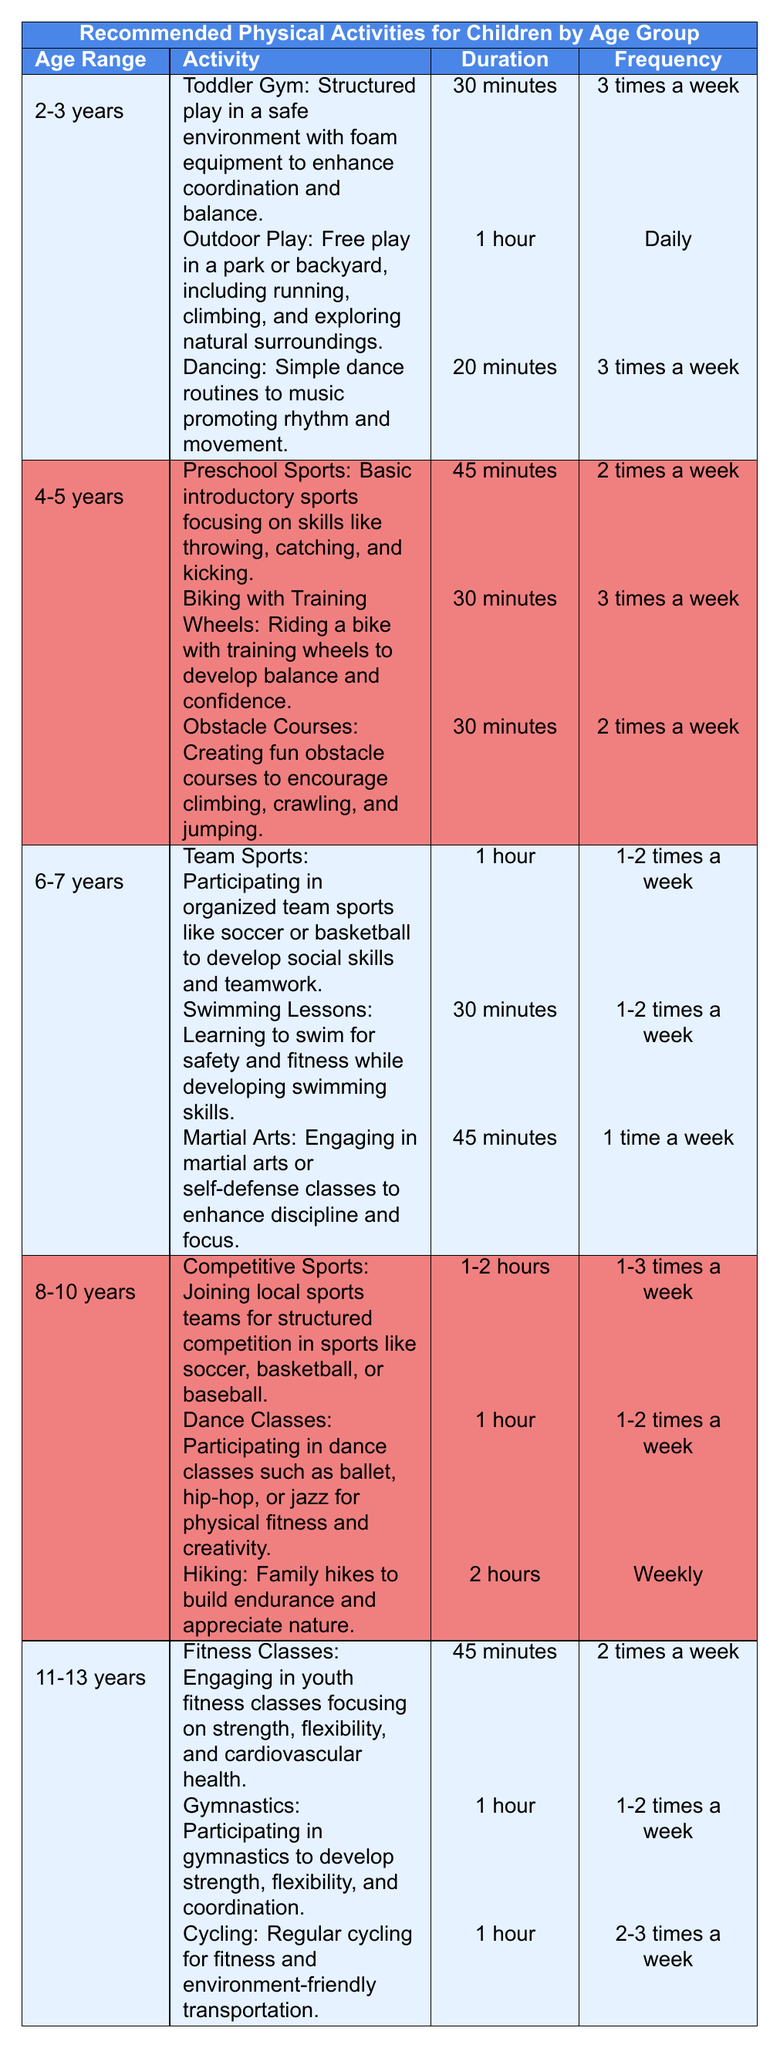What activities do children aged 4-5 years participate in? The table lists three activities for the age group 4-5 years: Preschool Sports, Biking with Training Wheels, and Obstacle Courses.
Answer: Preschool Sports, Biking with Training Wheels, Obstacle Courses How often should a child aged 2-3 years engage in dancing? According to the table, children aged 2-3 years should participate in dancing 3 times a week.
Answer: 3 times a week What is the duration of swimming lessons for children aged 6-7 years? The table specifies that swimming lessons for this age group last for 30 minutes.
Answer: 30 minutes Is it true that children aged 8-10 years have hiking as a recommended activity? The table indicates that hiking is listed as a recommended activity for children aged 8-10 years.
Answer: Yes What is the total duration of physical activities for children aged 11-13 years? The activities for 11-13 years are Fitness Classes (45 minutes), Gymnastics (1 hour), and Cycling (1 hour). Converting to minutes: 45 + 60 + 60 = 165 minutes.
Answer: 165 minutes What is the maximum frequency of competitive sports for children aged 8-10 years? The table shows that competitive sports can be practiced 1-3 times a week, so the maximum frequency is 3 times a week.
Answer: 3 times a week Which activity for children aged 6-7 years requires the most frequent engagement? Reviewing the frequency, Team Sports is set for 1-2 times a week, Swimming Lessons for 1-2 times a week, and Martial Arts for 1 time a week. The ones that allow for more frequency are Team Sports and Swimming Lessons.
Answer: Team Sports and Swimming Lessons What is the difference in frequency of outdoor play between children aged 2-3 years and competitive sports for children aged 8-10 years? Outdoor Play for children aged 2-3 years occurs daily while Competitive Sports can take place 1-3 times a week. Considering '1-3 times a week' suggests the minimum is once a week, the difference is daily (7 times a week) minus once = 6 times a week at most.
Answer: 6 times a week 